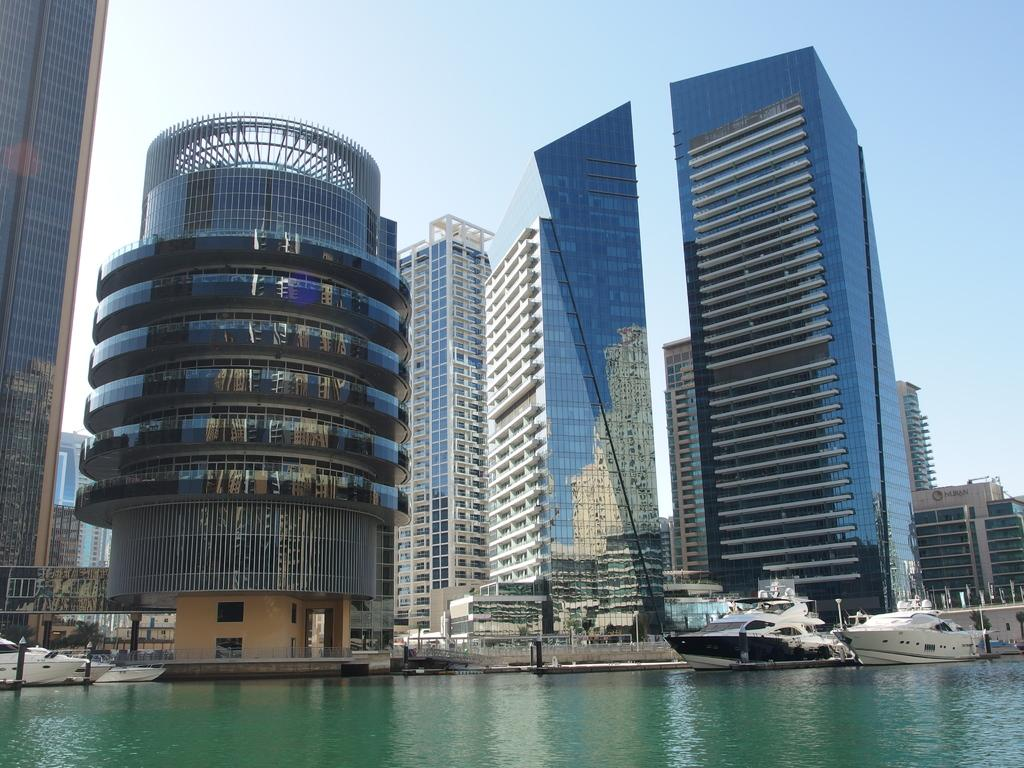What type of structures are present in the image? There are buildings in the image. What else can be seen in the image besides the buildings? There are poles and boats on the water visible in the image. What is the location of the boats in the image? The boats are on the water at the bottom of the image. What is visible at the top of the image? The sky is visible at the top of the image. What type of twig can be seen in the image? There is no twig present in the image. Can you tell me how much honey is being produced by the boats in the image? There is no honey production associated with the boats in the image. 